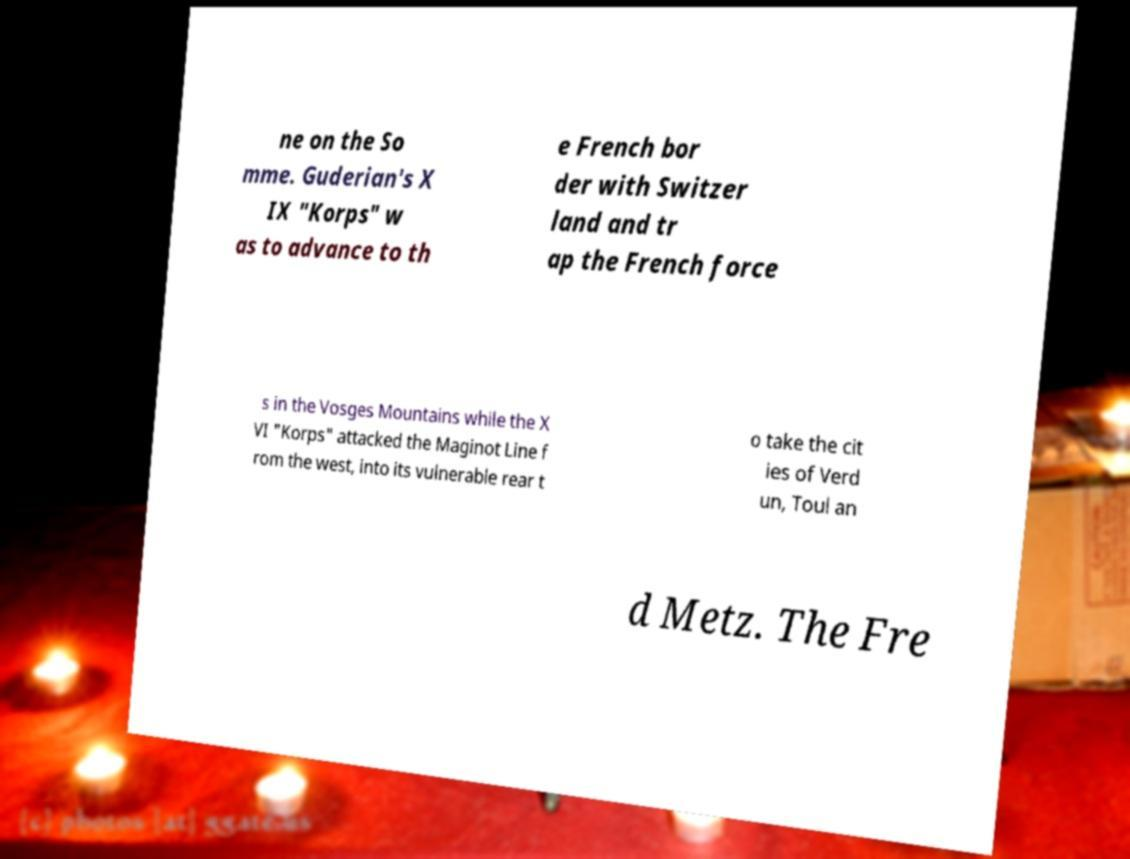Could you assist in decoding the text presented in this image and type it out clearly? ne on the So mme. Guderian's X IX "Korps" w as to advance to th e French bor der with Switzer land and tr ap the French force s in the Vosges Mountains while the X VI "Korps" attacked the Maginot Line f rom the west, into its vulnerable rear t o take the cit ies of Verd un, Toul an d Metz. The Fre 